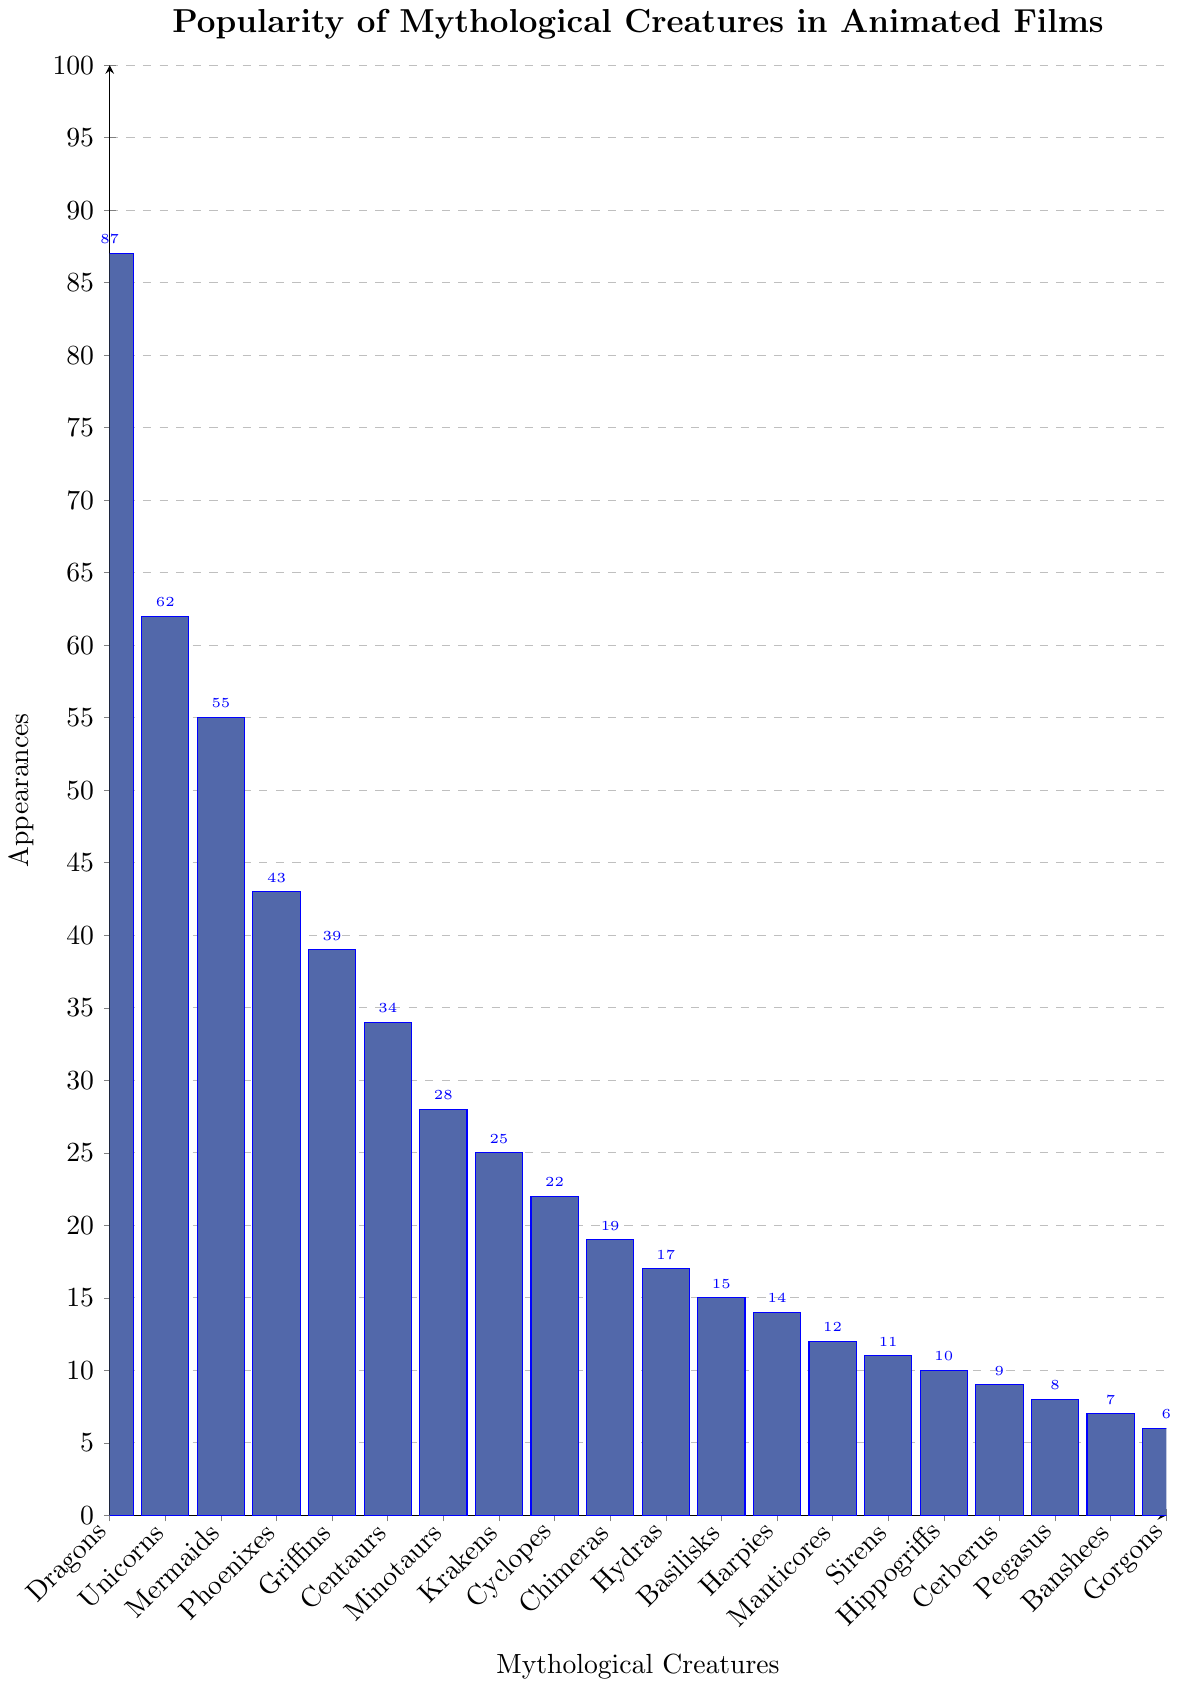What's the most frequently appearing mythological creature in animated films? The tallest bar in the chart corresponds to Dragons, which means they have the most appearances.
Answer: Dragons What is the total number of appearances for the top three creatures? The number of appearances for Dragons, Unicorns, and Mermaids are 87, 62, and 55 respectively. Summing these values: 87 + 62 + 55 = 204.
Answer: 204 Which creature appears more frequently: Phoenixes or Krakens? Phoenixes have a taller bar with 43 appearances, whereas Krakens have 25 appearances.
Answer: Phoenixes How many more appearances do Griffins have compared to Minotaurs? Griffins have 39 appearances, and Minotaurs have 28. The difference is 39 - 28 = 11.
Answer: 11 What’s the average number of appearances for creatures with over 50 appearances? The creatures with over 50 appearances are Dragons (87), Unicorns (62), and Mermaids (55). Adding these values: 87 + 62 + 55 = 204. The average is 204/3 ≈ 68.
Answer: 68 Are there more appearances of Krakens or Cyclopes, and by how much? Krakens have 25 appearances, and Cyclopes have 22. The difference is 25 - 22 = 3.
Answer: Krakens, 3 Which creatures have fewer than 10 appearances? The creatures with fewer than 10 appearances are Cerberus (9), Pegasus (8), Banshees (7), and Gorgons (6).
Answer: Cerberus, Pegasus, Banshees, Gorgons What is the total number of appearances for all the creatures combined? Summing the appearances of all creatures: 87 + 62 + 55 + 43 + 39 + 34 + 28 + 25 + 22 + 19 + 17 + 15 + 14 + 12 + 11 + 10 + 9 + 8 + 7 + 6 = 497.
Answer: 497 Which creature has the least number of appearances? The smallest bar in the chart corresponds to Gorgons, which have 6 appearances.
Answer: Gorgons What is the difference in appearances between the creature with the highest appearance and the creature with the lowest appearance? Dragons have the highest appearances at 87, and Gorgons have the lowest at 6. The difference is 87 - 6 = 81.
Answer: 81 